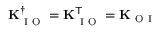<formula> <loc_0><loc_0><loc_500><loc_500>K _ { I O } ^ { \dagger } = K _ { I O } ^ { T } = K _ { O I }</formula> 